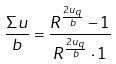Convert formula to latex. <formula><loc_0><loc_0><loc_500><loc_500>\frac { \Sigma u } { b } = \frac { R ^ { \frac { 2 u _ { q } } { b } } - 1 } { R ^ { \frac { 2 u _ { q } } { b } } \cdot 1 }</formula> 